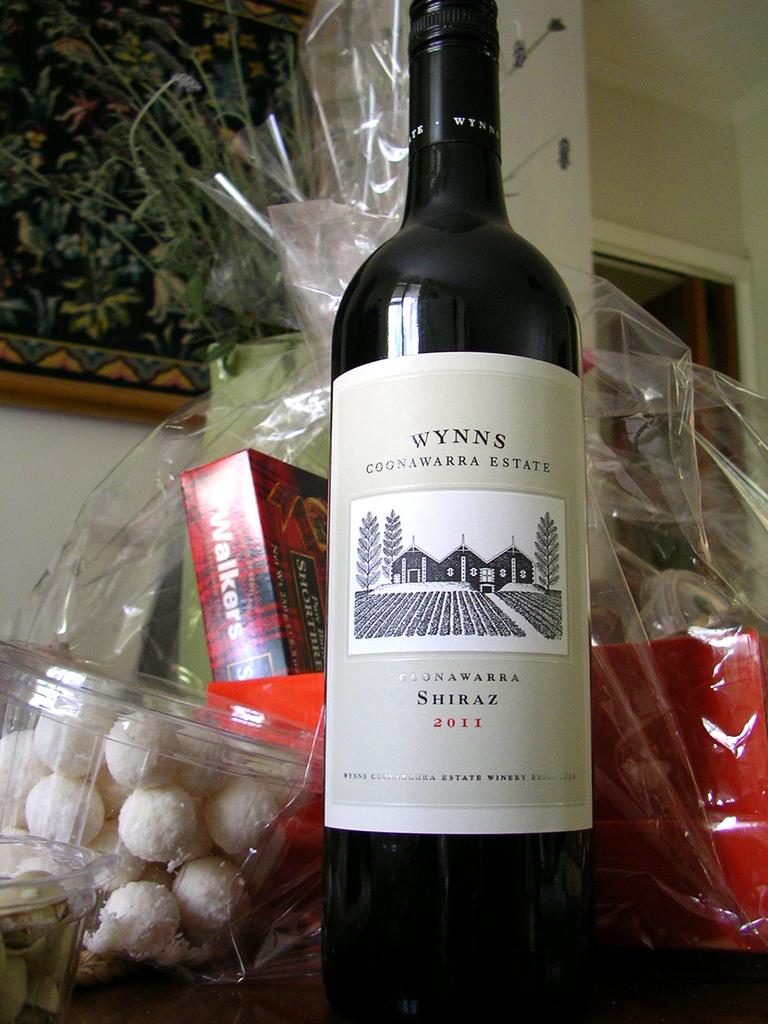What kind of wine is this?
Keep it short and to the point. Shiraz. 